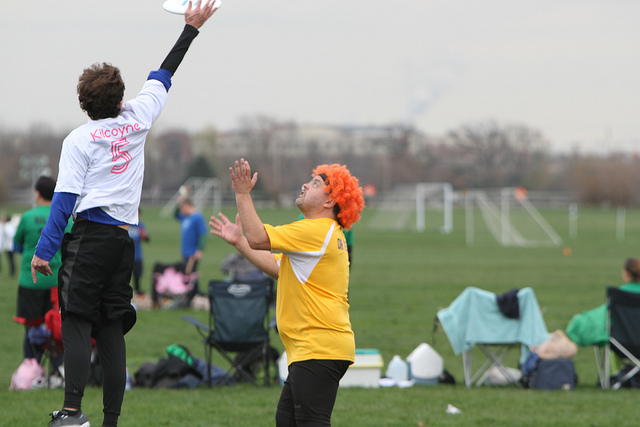Identify and read out the text in this image. Kilcoyne 5 